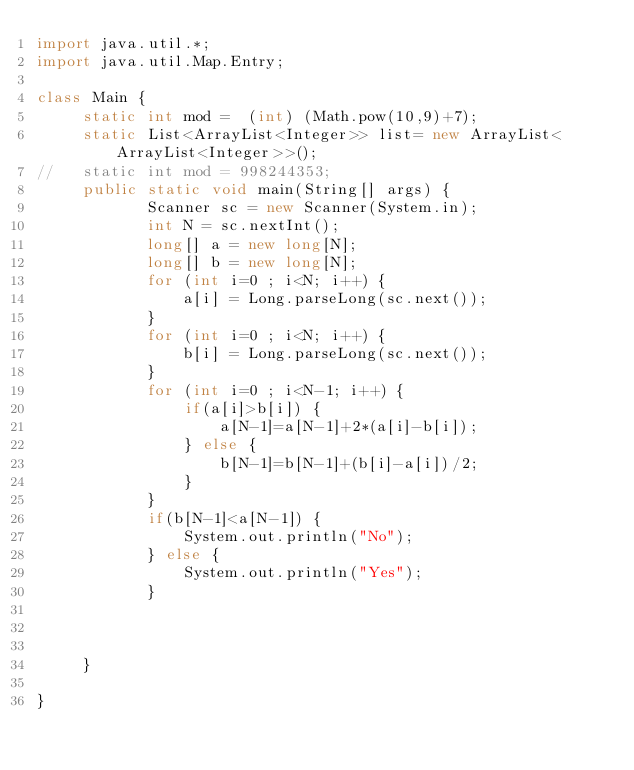Convert code to text. <code><loc_0><loc_0><loc_500><loc_500><_Java_>import java.util.*;
import java.util.Map.Entry;
 
class Main {
	 static int mod =  (int) (Math.pow(10,9)+7);
	 static List<ArrayList<Integer>> list= new ArrayList<ArrayList<Integer>>();
//	 static int mod = 998244353;
	 public static void main(String[] args) {
	        Scanner sc = new Scanner(System.in);
	        int N = sc.nextInt();	
	        long[] a = new long[N];
	        long[] b = new long[N];
	        for (int i=0 ; i<N; i++) {
	            a[i] = Long.parseLong(sc.next());
	        }
	        for (int i=0 ; i<N; i++) {
	            b[i] = Long.parseLong(sc.next());
	        }
	        for (int i=0 ; i<N-1; i++) {
	            if(a[i]>b[i]) {
	            	a[N-1]=a[N-1]+2*(a[i]-b[i]);
	            } else {
	            	b[N-1]=b[N-1]+(b[i]-a[i])/2;
	            }
	        }
	        if(b[N-1]<a[N-1]) {
	        	System.out.println("No");
	        } else {
	        	System.out.println("Yes");
	        }
	        
	        
	        
	 }

}</code> 